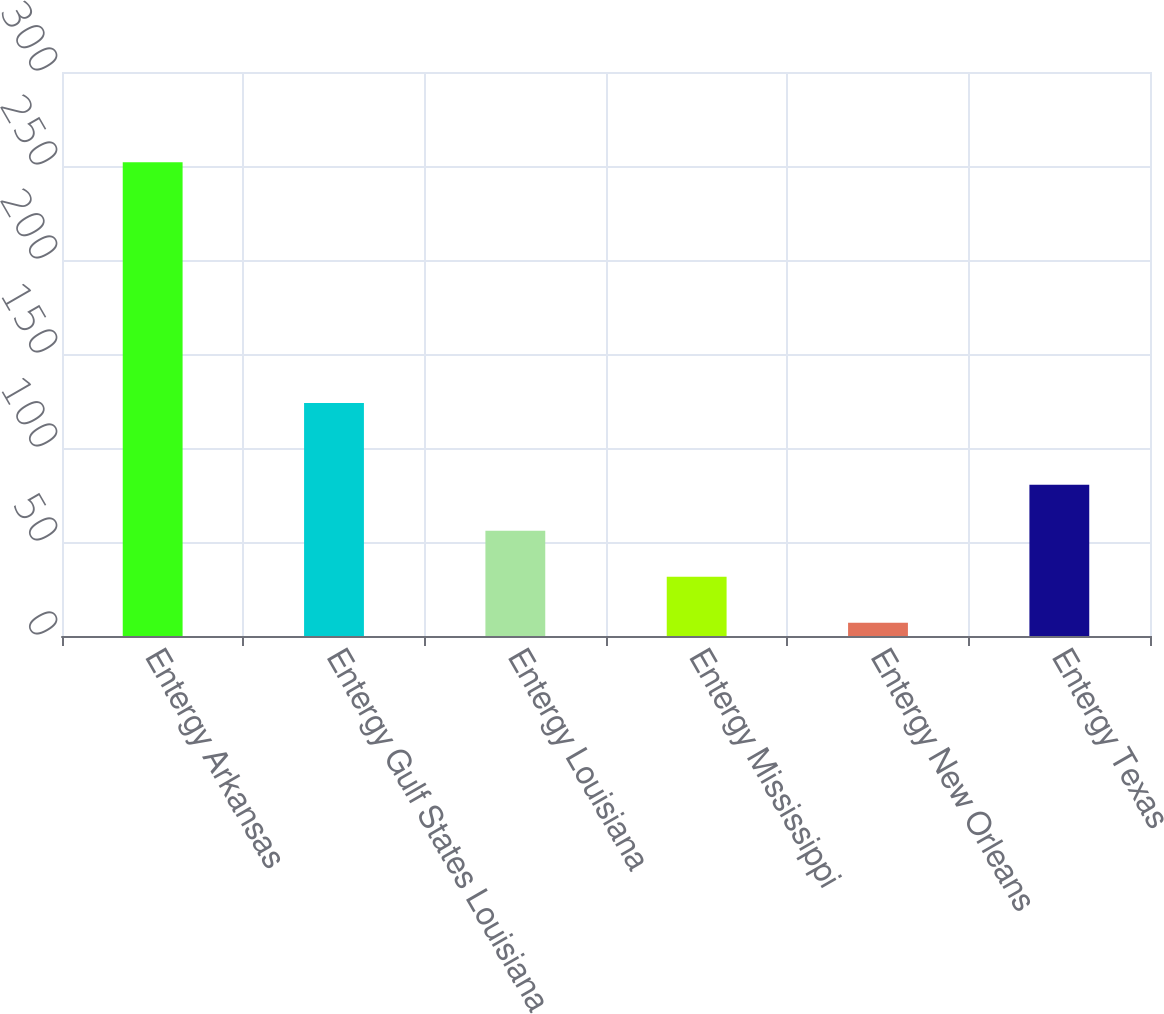Convert chart to OTSL. <chart><loc_0><loc_0><loc_500><loc_500><bar_chart><fcel>Entergy Arkansas<fcel>Entergy Gulf States Louisiana<fcel>Entergy Louisiana<fcel>Entergy Mississippi<fcel>Entergy New Orleans<fcel>Entergy Texas<nl><fcel>252<fcel>124<fcel>56<fcel>31.5<fcel>7<fcel>80.5<nl></chart> 